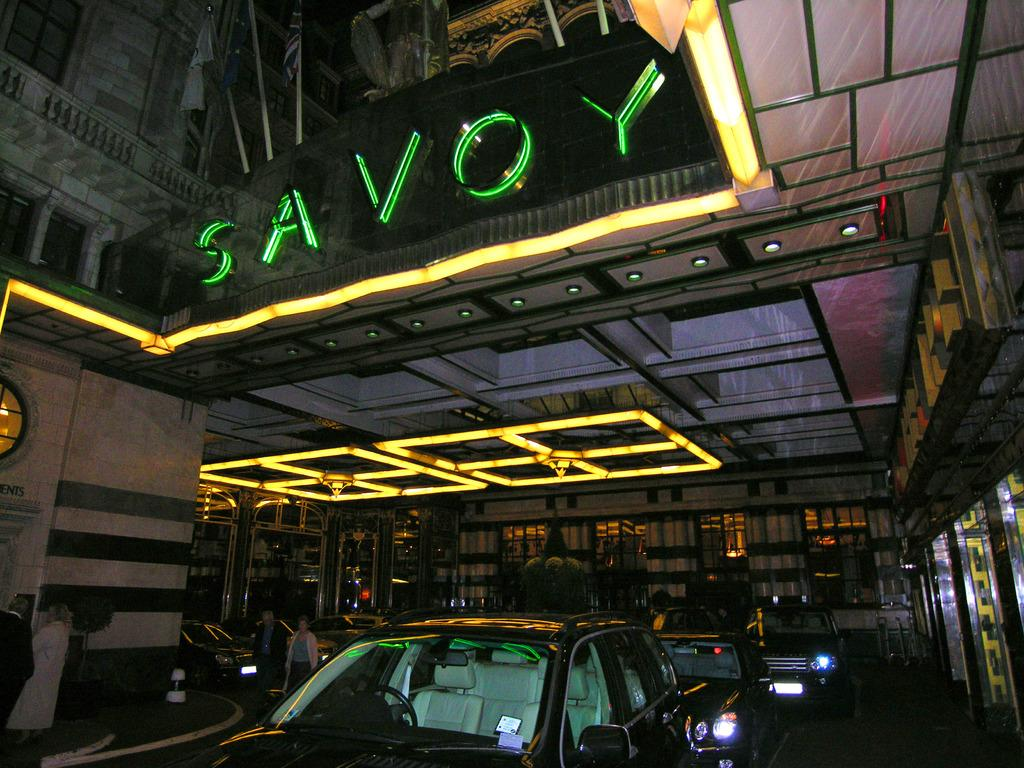Provide a one-sentence caption for the provided image. A carport that has the word Savoy above it in neon lighting. 